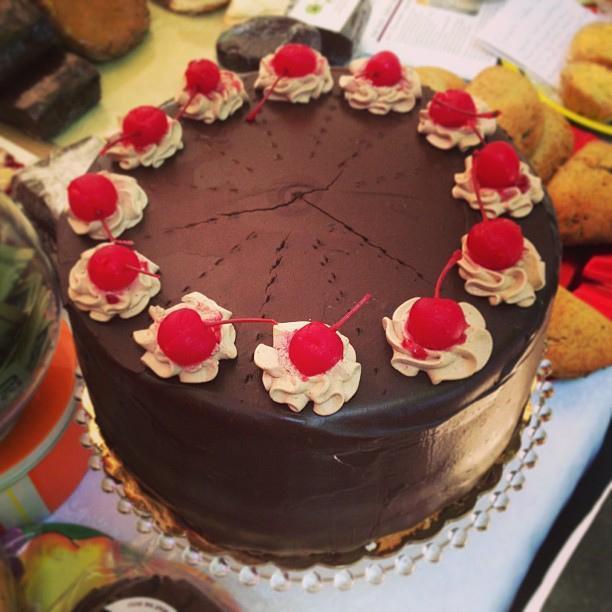How many slices are there?
Give a very brief answer. 12. How many birds are in the air?
Give a very brief answer. 0. 